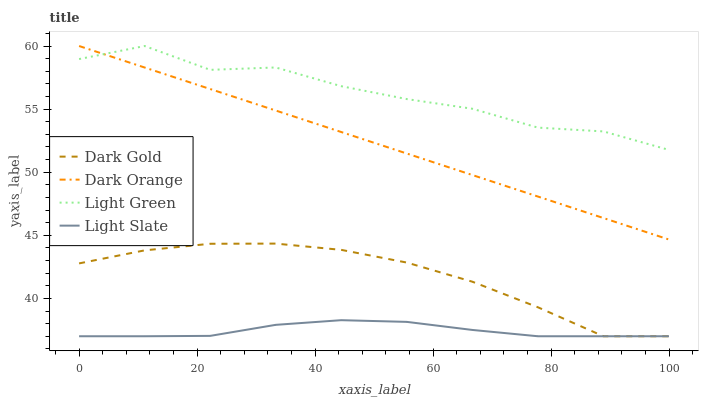Does Light Slate have the minimum area under the curve?
Answer yes or no. Yes. Does Light Green have the maximum area under the curve?
Answer yes or no. Yes. Does Dark Orange have the minimum area under the curve?
Answer yes or no. No. Does Dark Orange have the maximum area under the curve?
Answer yes or no. No. Is Dark Orange the smoothest?
Answer yes or no. Yes. Is Light Green the roughest?
Answer yes or no. Yes. Is Light Green the smoothest?
Answer yes or no. No. Is Dark Orange the roughest?
Answer yes or no. No. Does Light Slate have the lowest value?
Answer yes or no. Yes. Does Dark Orange have the lowest value?
Answer yes or no. No. Does Light Green have the highest value?
Answer yes or no. Yes. Does Dark Gold have the highest value?
Answer yes or no. No. Is Dark Gold less than Dark Orange?
Answer yes or no. Yes. Is Light Green greater than Dark Gold?
Answer yes or no. Yes. Does Light Green intersect Dark Orange?
Answer yes or no. Yes. Is Light Green less than Dark Orange?
Answer yes or no. No. Is Light Green greater than Dark Orange?
Answer yes or no. No. Does Dark Gold intersect Dark Orange?
Answer yes or no. No. 